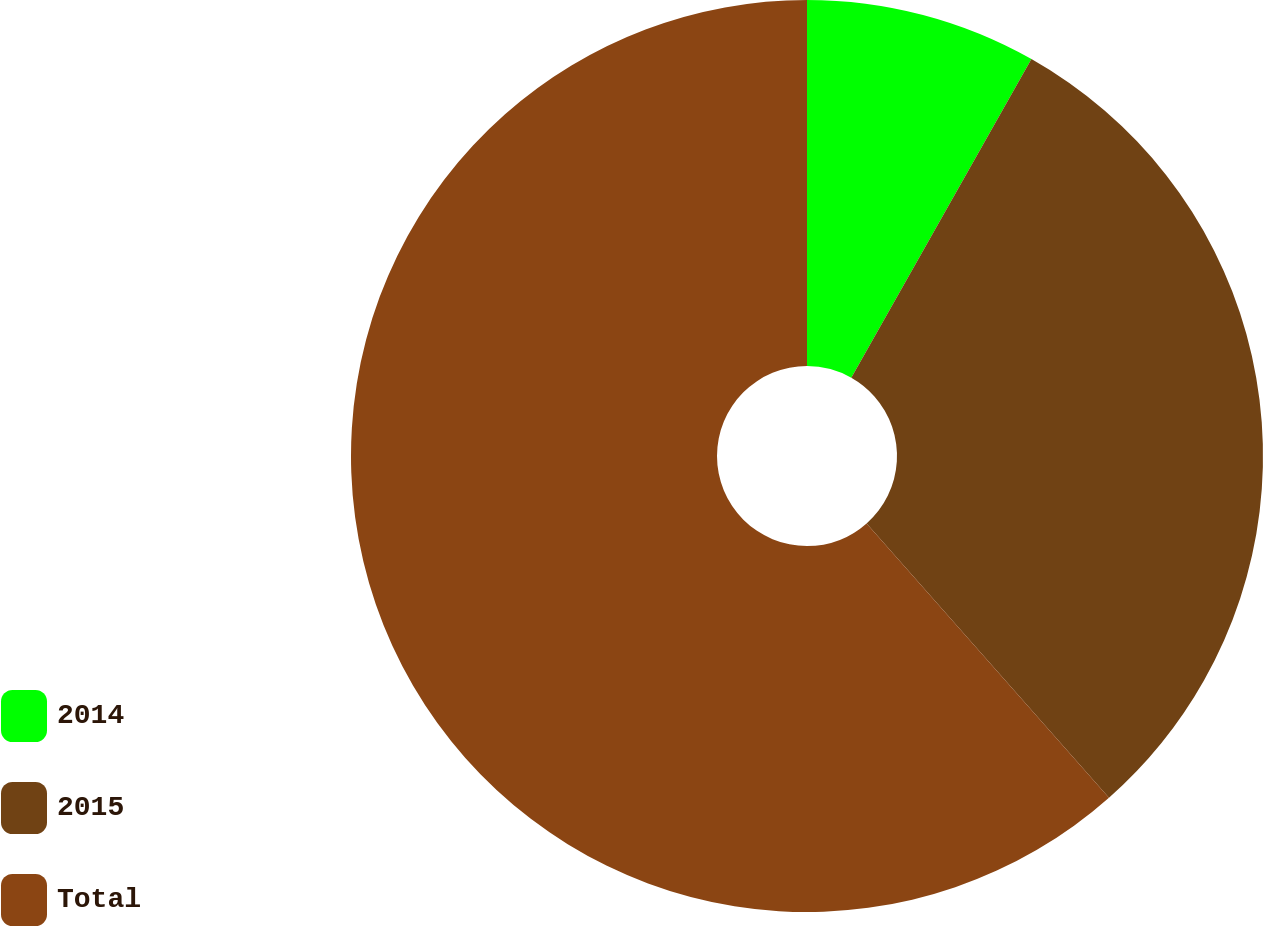<chart> <loc_0><loc_0><loc_500><loc_500><pie_chart><fcel>2014<fcel>2015<fcel>Total<nl><fcel>8.19%<fcel>30.29%<fcel>61.52%<nl></chart> 